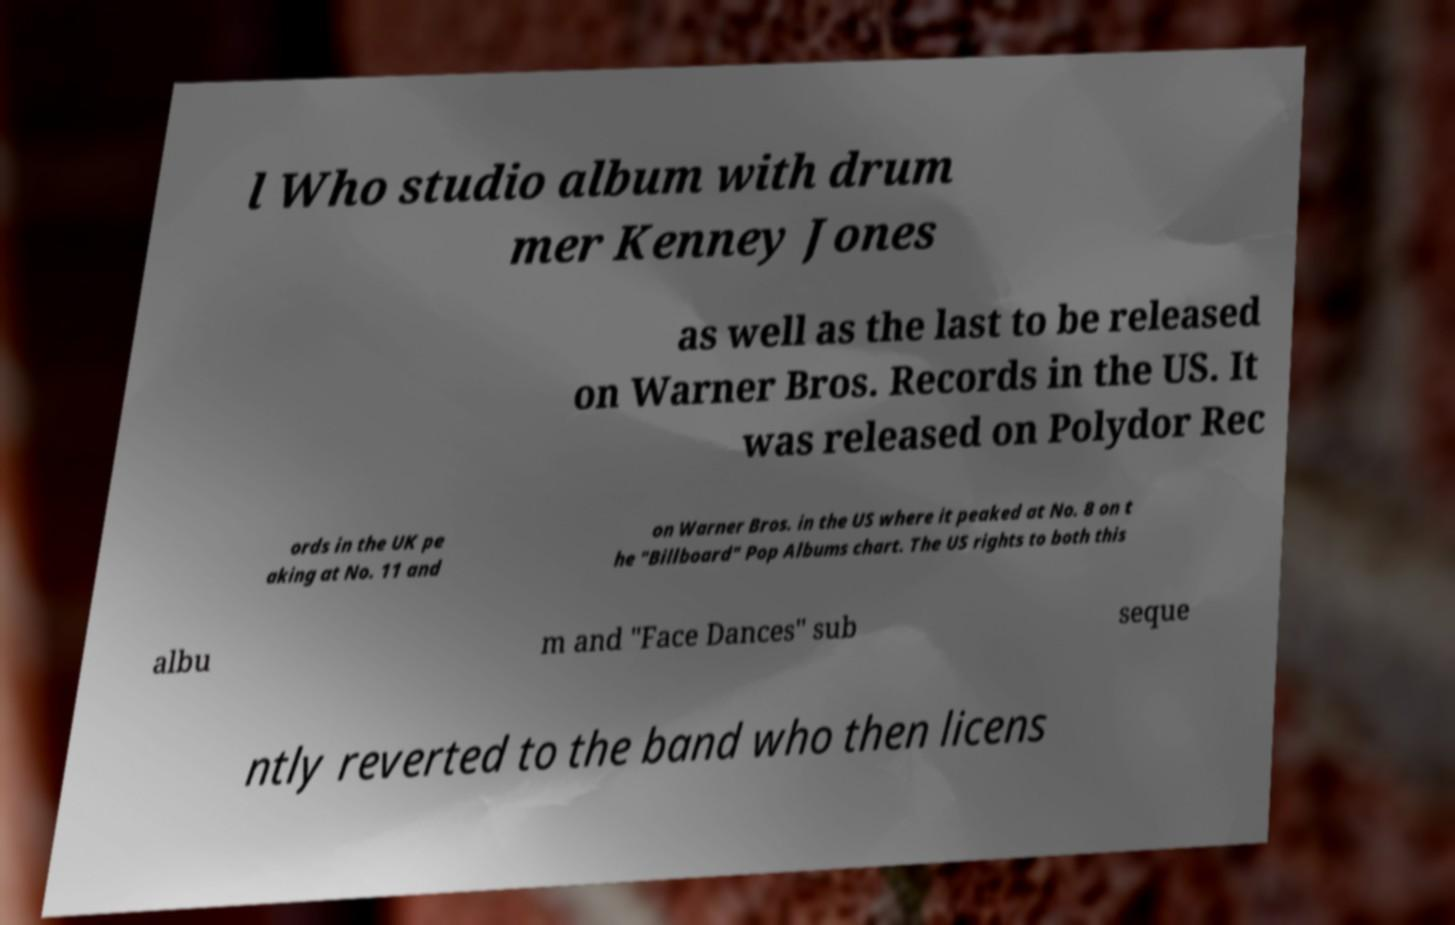Please read and relay the text visible in this image. What does it say? l Who studio album with drum mer Kenney Jones as well as the last to be released on Warner Bros. Records in the US. It was released on Polydor Rec ords in the UK pe aking at No. 11 and on Warner Bros. in the US where it peaked at No. 8 on t he "Billboard" Pop Albums chart. The US rights to both this albu m and "Face Dances" sub seque ntly reverted to the band who then licens 